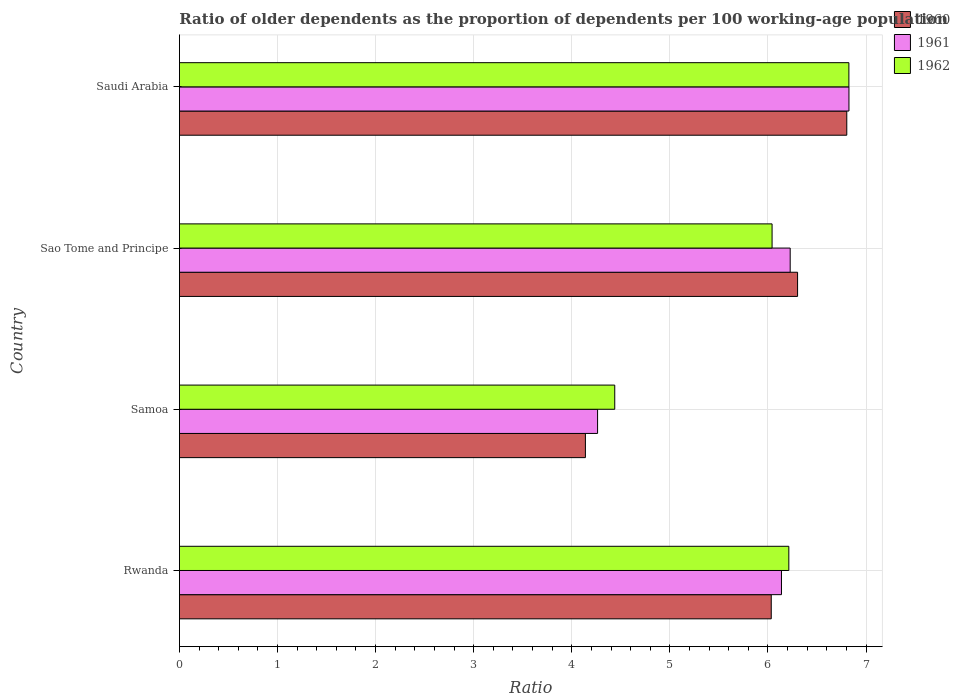What is the label of the 3rd group of bars from the top?
Make the answer very short. Samoa. What is the age dependency ratio(old) in 1961 in Saudi Arabia?
Your answer should be compact. 6.83. Across all countries, what is the maximum age dependency ratio(old) in 1961?
Keep it short and to the point. 6.83. Across all countries, what is the minimum age dependency ratio(old) in 1962?
Ensure brevity in your answer.  4.44. In which country was the age dependency ratio(old) in 1961 maximum?
Give a very brief answer. Saudi Arabia. In which country was the age dependency ratio(old) in 1960 minimum?
Keep it short and to the point. Samoa. What is the total age dependency ratio(old) in 1960 in the graph?
Offer a terse response. 23.28. What is the difference between the age dependency ratio(old) in 1960 in Rwanda and that in Sao Tome and Principe?
Ensure brevity in your answer.  -0.27. What is the difference between the age dependency ratio(old) in 1962 in Saudi Arabia and the age dependency ratio(old) in 1961 in Samoa?
Offer a terse response. 2.56. What is the average age dependency ratio(old) in 1961 per country?
Your answer should be compact. 5.86. What is the difference between the age dependency ratio(old) in 1960 and age dependency ratio(old) in 1962 in Saudi Arabia?
Give a very brief answer. -0.02. What is the ratio of the age dependency ratio(old) in 1962 in Samoa to that in Saudi Arabia?
Your answer should be compact. 0.65. Is the age dependency ratio(old) in 1961 in Samoa less than that in Saudi Arabia?
Offer a terse response. Yes. Is the difference between the age dependency ratio(old) in 1960 in Sao Tome and Principe and Saudi Arabia greater than the difference between the age dependency ratio(old) in 1962 in Sao Tome and Principe and Saudi Arabia?
Your answer should be very brief. Yes. What is the difference between the highest and the second highest age dependency ratio(old) in 1962?
Your answer should be very brief. 0.61. What is the difference between the highest and the lowest age dependency ratio(old) in 1962?
Your response must be concise. 2.39. In how many countries, is the age dependency ratio(old) in 1961 greater than the average age dependency ratio(old) in 1961 taken over all countries?
Make the answer very short. 3. Is the sum of the age dependency ratio(old) in 1961 in Samoa and Sao Tome and Principe greater than the maximum age dependency ratio(old) in 1962 across all countries?
Your answer should be very brief. Yes. What does the 3rd bar from the bottom in Rwanda represents?
Provide a succinct answer. 1962. Is it the case that in every country, the sum of the age dependency ratio(old) in 1961 and age dependency ratio(old) in 1962 is greater than the age dependency ratio(old) in 1960?
Your response must be concise. Yes. How many countries are there in the graph?
Make the answer very short. 4. What is the difference between two consecutive major ticks on the X-axis?
Offer a very short reply. 1. Are the values on the major ticks of X-axis written in scientific E-notation?
Provide a succinct answer. No. How are the legend labels stacked?
Provide a short and direct response. Vertical. What is the title of the graph?
Provide a short and direct response. Ratio of older dependents as the proportion of dependents per 100 working-age population. Does "1979" appear as one of the legend labels in the graph?
Offer a very short reply. No. What is the label or title of the X-axis?
Keep it short and to the point. Ratio. What is the Ratio in 1960 in Rwanda?
Provide a succinct answer. 6.03. What is the Ratio of 1961 in Rwanda?
Offer a terse response. 6.14. What is the Ratio of 1962 in Rwanda?
Offer a very short reply. 6.21. What is the Ratio of 1960 in Samoa?
Keep it short and to the point. 4.14. What is the Ratio in 1961 in Samoa?
Your answer should be compact. 4.26. What is the Ratio in 1962 in Samoa?
Keep it short and to the point. 4.44. What is the Ratio of 1960 in Sao Tome and Principe?
Offer a very short reply. 6.3. What is the Ratio of 1961 in Sao Tome and Principe?
Give a very brief answer. 6.23. What is the Ratio in 1962 in Sao Tome and Principe?
Give a very brief answer. 6.04. What is the Ratio in 1960 in Saudi Arabia?
Ensure brevity in your answer.  6.8. What is the Ratio of 1961 in Saudi Arabia?
Provide a short and direct response. 6.83. What is the Ratio of 1962 in Saudi Arabia?
Your response must be concise. 6.83. Across all countries, what is the maximum Ratio in 1960?
Your answer should be very brief. 6.8. Across all countries, what is the maximum Ratio in 1961?
Offer a very short reply. 6.83. Across all countries, what is the maximum Ratio of 1962?
Provide a short and direct response. 6.83. Across all countries, what is the minimum Ratio in 1960?
Ensure brevity in your answer.  4.14. Across all countries, what is the minimum Ratio in 1961?
Provide a short and direct response. 4.26. Across all countries, what is the minimum Ratio of 1962?
Offer a very short reply. 4.44. What is the total Ratio of 1960 in the graph?
Your answer should be very brief. 23.28. What is the total Ratio of 1961 in the graph?
Offer a very short reply. 23.45. What is the total Ratio in 1962 in the graph?
Keep it short and to the point. 23.52. What is the difference between the Ratio of 1960 in Rwanda and that in Samoa?
Offer a terse response. 1.89. What is the difference between the Ratio in 1961 in Rwanda and that in Samoa?
Keep it short and to the point. 1.87. What is the difference between the Ratio of 1962 in Rwanda and that in Samoa?
Offer a very short reply. 1.77. What is the difference between the Ratio in 1960 in Rwanda and that in Sao Tome and Principe?
Give a very brief answer. -0.27. What is the difference between the Ratio of 1961 in Rwanda and that in Sao Tome and Principe?
Your answer should be very brief. -0.09. What is the difference between the Ratio in 1962 in Rwanda and that in Sao Tome and Principe?
Offer a very short reply. 0.17. What is the difference between the Ratio in 1960 in Rwanda and that in Saudi Arabia?
Make the answer very short. -0.77. What is the difference between the Ratio of 1961 in Rwanda and that in Saudi Arabia?
Your response must be concise. -0.69. What is the difference between the Ratio of 1962 in Rwanda and that in Saudi Arabia?
Your response must be concise. -0.61. What is the difference between the Ratio in 1960 in Samoa and that in Sao Tome and Principe?
Offer a terse response. -2.16. What is the difference between the Ratio in 1961 in Samoa and that in Sao Tome and Principe?
Your answer should be compact. -1.96. What is the difference between the Ratio of 1962 in Samoa and that in Sao Tome and Principe?
Your response must be concise. -1.6. What is the difference between the Ratio in 1960 in Samoa and that in Saudi Arabia?
Your response must be concise. -2.66. What is the difference between the Ratio in 1961 in Samoa and that in Saudi Arabia?
Your response must be concise. -2.56. What is the difference between the Ratio of 1962 in Samoa and that in Saudi Arabia?
Provide a short and direct response. -2.39. What is the difference between the Ratio in 1960 in Sao Tome and Principe and that in Saudi Arabia?
Your answer should be compact. -0.5. What is the difference between the Ratio in 1961 in Sao Tome and Principe and that in Saudi Arabia?
Provide a short and direct response. -0.6. What is the difference between the Ratio in 1962 in Sao Tome and Principe and that in Saudi Arabia?
Your answer should be very brief. -0.78. What is the difference between the Ratio in 1960 in Rwanda and the Ratio in 1961 in Samoa?
Ensure brevity in your answer.  1.77. What is the difference between the Ratio in 1960 in Rwanda and the Ratio in 1962 in Samoa?
Offer a very short reply. 1.6. What is the difference between the Ratio of 1961 in Rwanda and the Ratio of 1962 in Samoa?
Ensure brevity in your answer.  1.7. What is the difference between the Ratio of 1960 in Rwanda and the Ratio of 1961 in Sao Tome and Principe?
Make the answer very short. -0.19. What is the difference between the Ratio of 1960 in Rwanda and the Ratio of 1962 in Sao Tome and Principe?
Ensure brevity in your answer.  -0.01. What is the difference between the Ratio of 1961 in Rwanda and the Ratio of 1962 in Sao Tome and Principe?
Give a very brief answer. 0.1. What is the difference between the Ratio of 1960 in Rwanda and the Ratio of 1961 in Saudi Arabia?
Provide a succinct answer. -0.79. What is the difference between the Ratio of 1960 in Rwanda and the Ratio of 1962 in Saudi Arabia?
Make the answer very short. -0.79. What is the difference between the Ratio of 1961 in Rwanda and the Ratio of 1962 in Saudi Arabia?
Provide a short and direct response. -0.69. What is the difference between the Ratio in 1960 in Samoa and the Ratio in 1961 in Sao Tome and Principe?
Provide a succinct answer. -2.09. What is the difference between the Ratio in 1960 in Samoa and the Ratio in 1962 in Sao Tome and Principe?
Ensure brevity in your answer.  -1.9. What is the difference between the Ratio of 1961 in Samoa and the Ratio of 1962 in Sao Tome and Principe?
Provide a short and direct response. -1.78. What is the difference between the Ratio in 1960 in Samoa and the Ratio in 1961 in Saudi Arabia?
Keep it short and to the point. -2.69. What is the difference between the Ratio of 1960 in Samoa and the Ratio of 1962 in Saudi Arabia?
Give a very brief answer. -2.69. What is the difference between the Ratio of 1961 in Samoa and the Ratio of 1962 in Saudi Arabia?
Your answer should be compact. -2.56. What is the difference between the Ratio in 1960 in Sao Tome and Principe and the Ratio in 1961 in Saudi Arabia?
Make the answer very short. -0.52. What is the difference between the Ratio in 1960 in Sao Tome and Principe and the Ratio in 1962 in Saudi Arabia?
Provide a short and direct response. -0.52. What is the difference between the Ratio of 1961 in Sao Tome and Principe and the Ratio of 1962 in Saudi Arabia?
Make the answer very short. -0.6. What is the average Ratio of 1960 per country?
Your answer should be very brief. 5.82. What is the average Ratio of 1961 per country?
Offer a very short reply. 5.86. What is the average Ratio in 1962 per country?
Offer a terse response. 5.88. What is the difference between the Ratio in 1960 and Ratio in 1961 in Rwanda?
Make the answer very short. -0.1. What is the difference between the Ratio in 1960 and Ratio in 1962 in Rwanda?
Make the answer very short. -0.18. What is the difference between the Ratio of 1961 and Ratio of 1962 in Rwanda?
Make the answer very short. -0.07. What is the difference between the Ratio of 1960 and Ratio of 1961 in Samoa?
Your answer should be very brief. -0.12. What is the difference between the Ratio in 1960 and Ratio in 1962 in Samoa?
Provide a succinct answer. -0.3. What is the difference between the Ratio of 1961 and Ratio of 1962 in Samoa?
Keep it short and to the point. -0.17. What is the difference between the Ratio of 1960 and Ratio of 1961 in Sao Tome and Principe?
Provide a succinct answer. 0.08. What is the difference between the Ratio in 1960 and Ratio in 1962 in Sao Tome and Principe?
Provide a succinct answer. 0.26. What is the difference between the Ratio of 1961 and Ratio of 1962 in Sao Tome and Principe?
Keep it short and to the point. 0.18. What is the difference between the Ratio of 1960 and Ratio of 1961 in Saudi Arabia?
Ensure brevity in your answer.  -0.02. What is the difference between the Ratio in 1960 and Ratio in 1962 in Saudi Arabia?
Offer a terse response. -0.02. What is the difference between the Ratio in 1961 and Ratio in 1962 in Saudi Arabia?
Your response must be concise. 0. What is the ratio of the Ratio of 1960 in Rwanda to that in Samoa?
Your answer should be very brief. 1.46. What is the ratio of the Ratio in 1961 in Rwanda to that in Samoa?
Your response must be concise. 1.44. What is the ratio of the Ratio in 1962 in Rwanda to that in Samoa?
Your answer should be very brief. 1.4. What is the ratio of the Ratio in 1960 in Rwanda to that in Sao Tome and Principe?
Make the answer very short. 0.96. What is the ratio of the Ratio of 1961 in Rwanda to that in Sao Tome and Principe?
Offer a terse response. 0.99. What is the ratio of the Ratio of 1962 in Rwanda to that in Sao Tome and Principe?
Your answer should be very brief. 1.03. What is the ratio of the Ratio in 1960 in Rwanda to that in Saudi Arabia?
Give a very brief answer. 0.89. What is the ratio of the Ratio of 1961 in Rwanda to that in Saudi Arabia?
Keep it short and to the point. 0.9. What is the ratio of the Ratio of 1962 in Rwanda to that in Saudi Arabia?
Keep it short and to the point. 0.91. What is the ratio of the Ratio in 1960 in Samoa to that in Sao Tome and Principe?
Make the answer very short. 0.66. What is the ratio of the Ratio in 1961 in Samoa to that in Sao Tome and Principe?
Provide a succinct answer. 0.68. What is the ratio of the Ratio in 1962 in Samoa to that in Sao Tome and Principe?
Ensure brevity in your answer.  0.73. What is the ratio of the Ratio of 1960 in Samoa to that in Saudi Arabia?
Your response must be concise. 0.61. What is the ratio of the Ratio of 1961 in Samoa to that in Saudi Arabia?
Give a very brief answer. 0.62. What is the ratio of the Ratio in 1962 in Samoa to that in Saudi Arabia?
Provide a succinct answer. 0.65. What is the ratio of the Ratio of 1960 in Sao Tome and Principe to that in Saudi Arabia?
Your answer should be very brief. 0.93. What is the ratio of the Ratio in 1961 in Sao Tome and Principe to that in Saudi Arabia?
Ensure brevity in your answer.  0.91. What is the ratio of the Ratio in 1962 in Sao Tome and Principe to that in Saudi Arabia?
Give a very brief answer. 0.89. What is the difference between the highest and the second highest Ratio in 1960?
Ensure brevity in your answer.  0.5. What is the difference between the highest and the second highest Ratio in 1961?
Make the answer very short. 0.6. What is the difference between the highest and the second highest Ratio of 1962?
Provide a succinct answer. 0.61. What is the difference between the highest and the lowest Ratio in 1960?
Provide a short and direct response. 2.66. What is the difference between the highest and the lowest Ratio in 1961?
Give a very brief answer. 2.56. What is the difference between the highest and the lowest Ratio of 1962?
Offer a terse response. 2.39. 